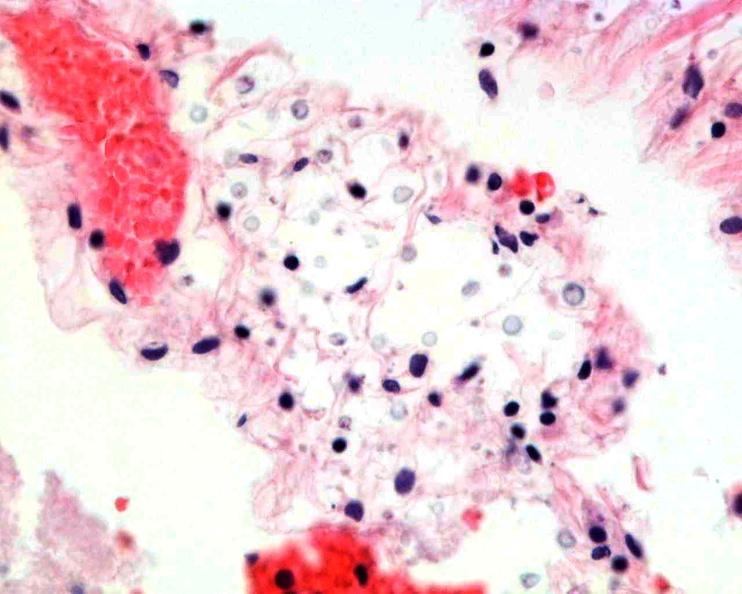what does this image show?
Answer the question using a single word or phrase. Brain 